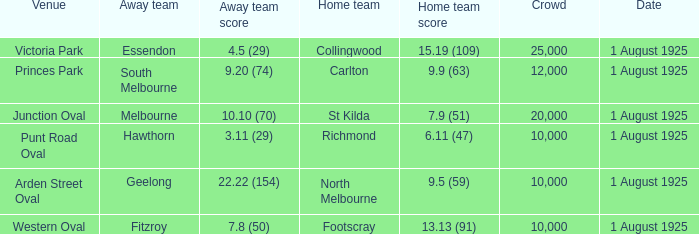Could you help me parse every detail presented in this table? {'header': ['Venue', 'Away team', 'Away team score', 'Home team', 'Home team score', 'Crowd', 'Date'], 'rows': [['Victoria Park', 'Essendon', '4.5 (29)', 'Collingwood', '15.19 (109)', '25,000', '1 August 1925'], ['Princes Park', 'South Melbourne', '9.20 (74)', 'Carlton', '9.9 (63)', '12,000', '1 August 1925'], ['Junction Oval', 'Melbourne', '10.10 (70)', 'St Kilda', '7.9 (51)', '20,000', '1 August 1925'], ['Punt Road Oval', 'Hawthorn', '3.11 (29)', 'Richmond', '6.11 (47)', '10,000', '1 August 1925'], ['Arden Street Oval', 'Geelong', '22.22 (154)', 'North Melbourne', '9.5 (59)', '10,000', '1 August 1925'], ['Western Oval', 'Fitzroy', '7.8 (50)', 'Footscray', '13.13 (91)', '10,000', '1 August 1925']]} When did the match take place that had a home team score of 7.9 (51)? 1 August 1925. 